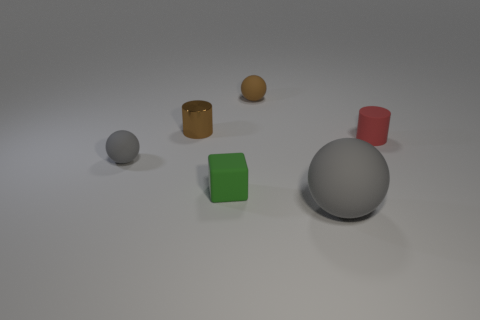There is another object that is the same color as the big object; what size is it?
Provide a succinct answer. Small. What shape is the small rubber thing that is the same color as the metallic cylinder?
Provide a short and direct response. Sphere. Is the number of red cylinders greater than the number of balls?
Offer a very short reply. No. Are there any other metal objects of the same size as the green object?
Provide a succinct answer. Yes. What number of things are either things to the left of the tiny red cylinder or cylinders to the left of the large gray matte sphere?
Make the answer very short. 5. What is the color of the small thing that is on the right side of the ball that is behind the red object?
Make the answer very short. Red. What is the color of the cylinder that is the same material as the cube?
Provide a short and direct response. Red. How many large things are the same color as the matte cube?
Keep it short and to the point. 0. How many objects are tiny rubber cylinders or blue matte cylinders?
Provide a short and direct response. 1. What shape is the gray object that is the same size as the green rubber object?
Ensure brevity in your answer.  Sphere. 